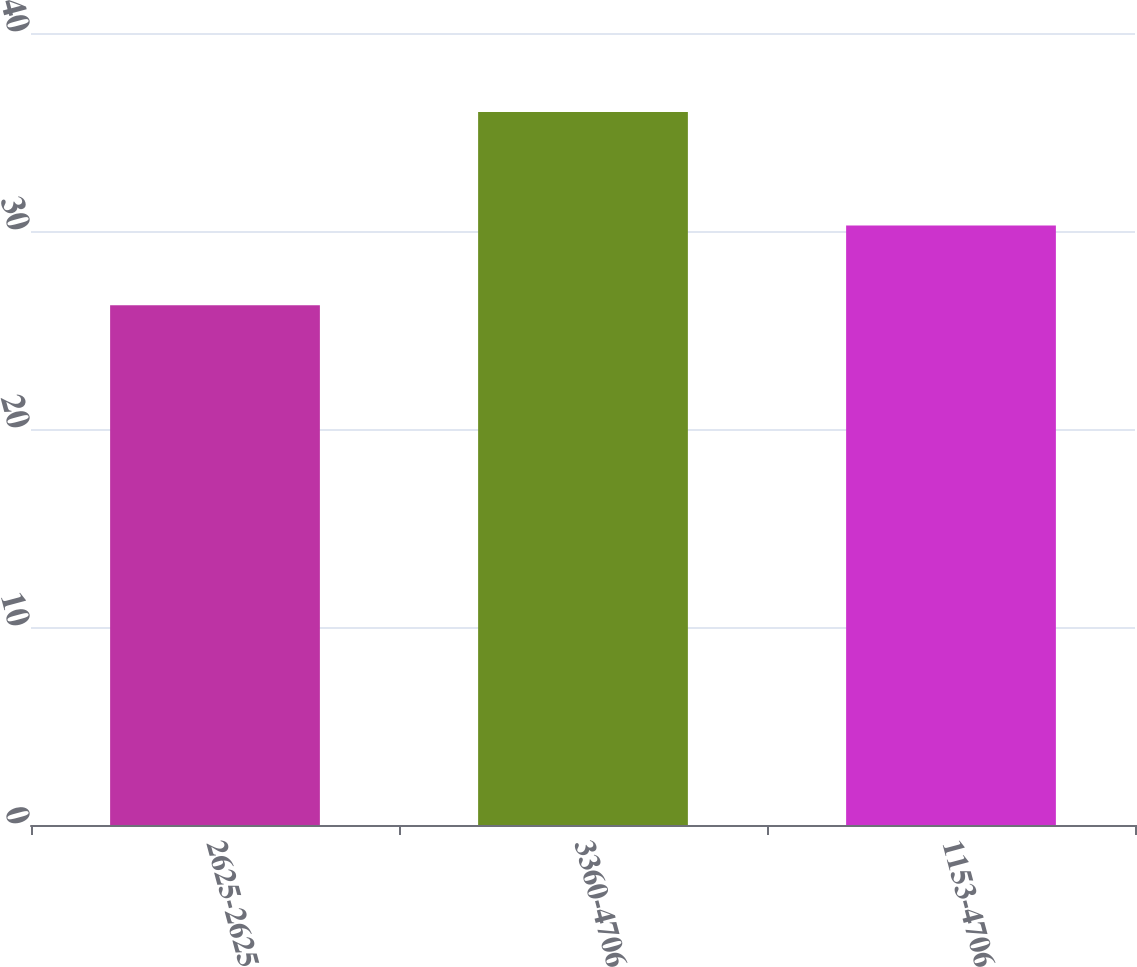<chart> <loc_0><loc_0><loc_500><loc_500><bar_chart><fcel>2625-2625<fcel>3360-4706<fcel>1153-4706<nl><fcel>26.25<fcel>36.01<fcel>30.28<nl></chart> 